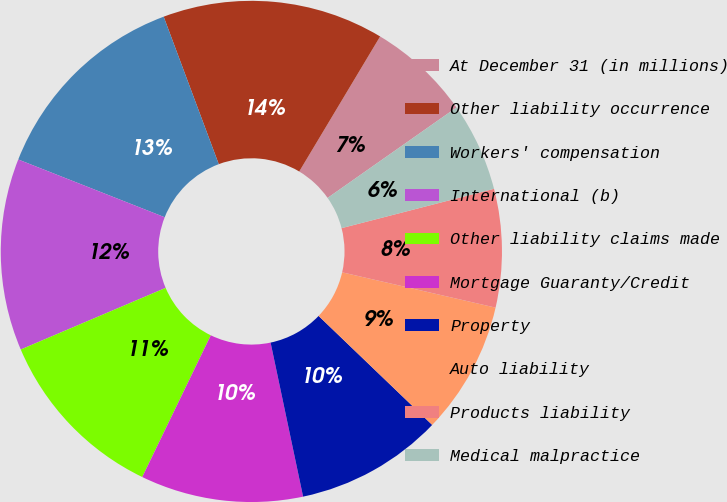Convert chart. <chart><loc_0><loc_0><loc_500><loc_500><pie_chart><fcel>At December 31 (in millions)<fcel>Other liability occurrence<fcel>Workers' compensation<fcel>International (b)<fcel>Other liability claims made<fcel>Mortgage Guaranty/Credit<fcel>Property<fcel>Auto liability<fcel>Products liability<fcel>Medical malpractice<nl><fcel>6.67%<fcel>14.28%<fcel>13.33%<fcel>12.38%<fcel>11.43%<fcel>10.48%<fcel>9.52%<fcel>8.57%<fcel>7.62%<fcel>5.72%<nl></chart> 